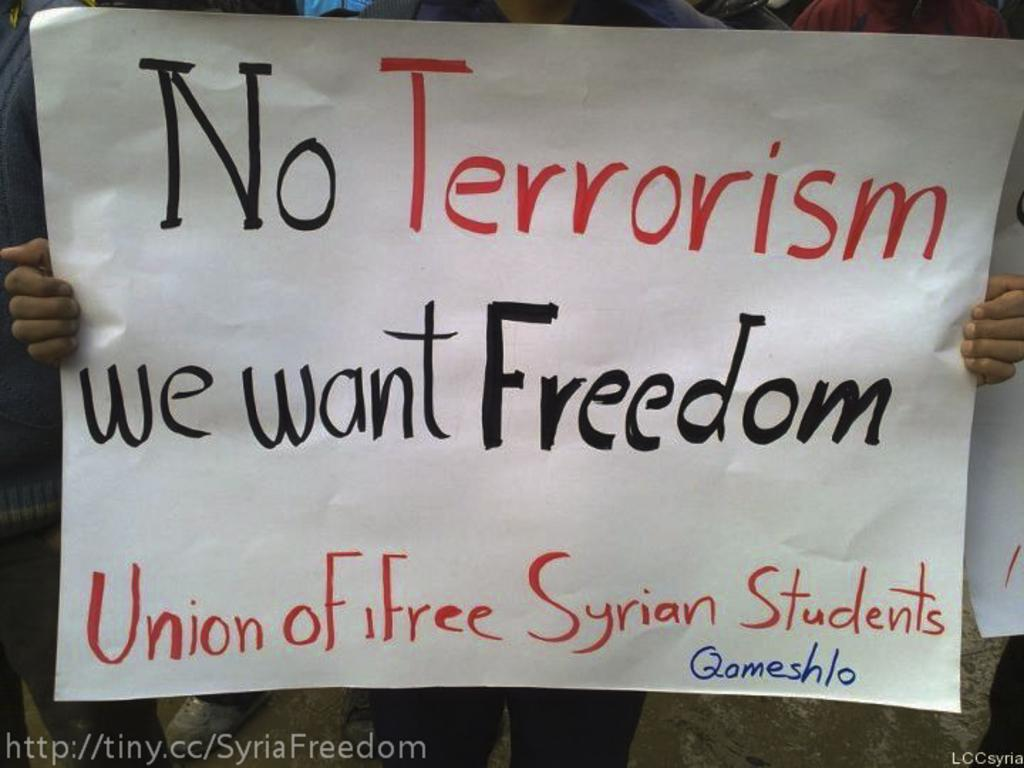What is the person in the foreground holding in the image? The person is holding a paper with text written on it. Can you describe the people in the background? There are other persons visible in the background. What else can be seen in the background? There is a paper present in the background. What invention is the person using to jump higher in the image? There is no invention or jumping activity present in the image. 